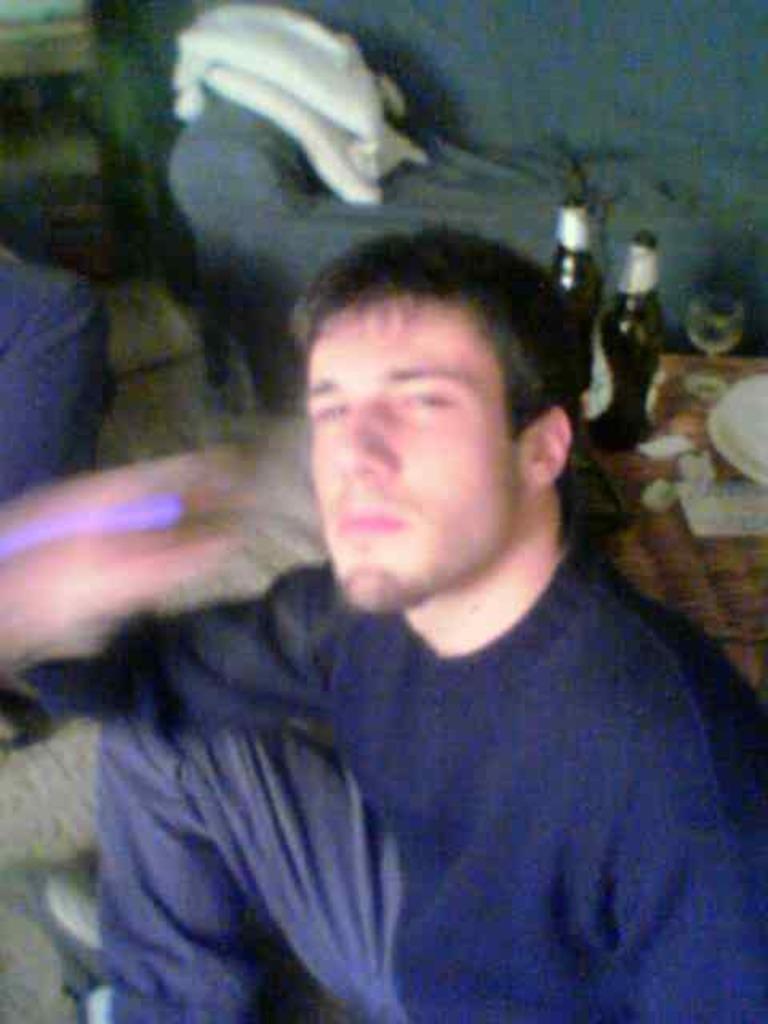Please provide a concise description of this image. In the image we can see a man sitting and wearing clothes. Here we can see two bottles, a wine glass and the background is blurred.  